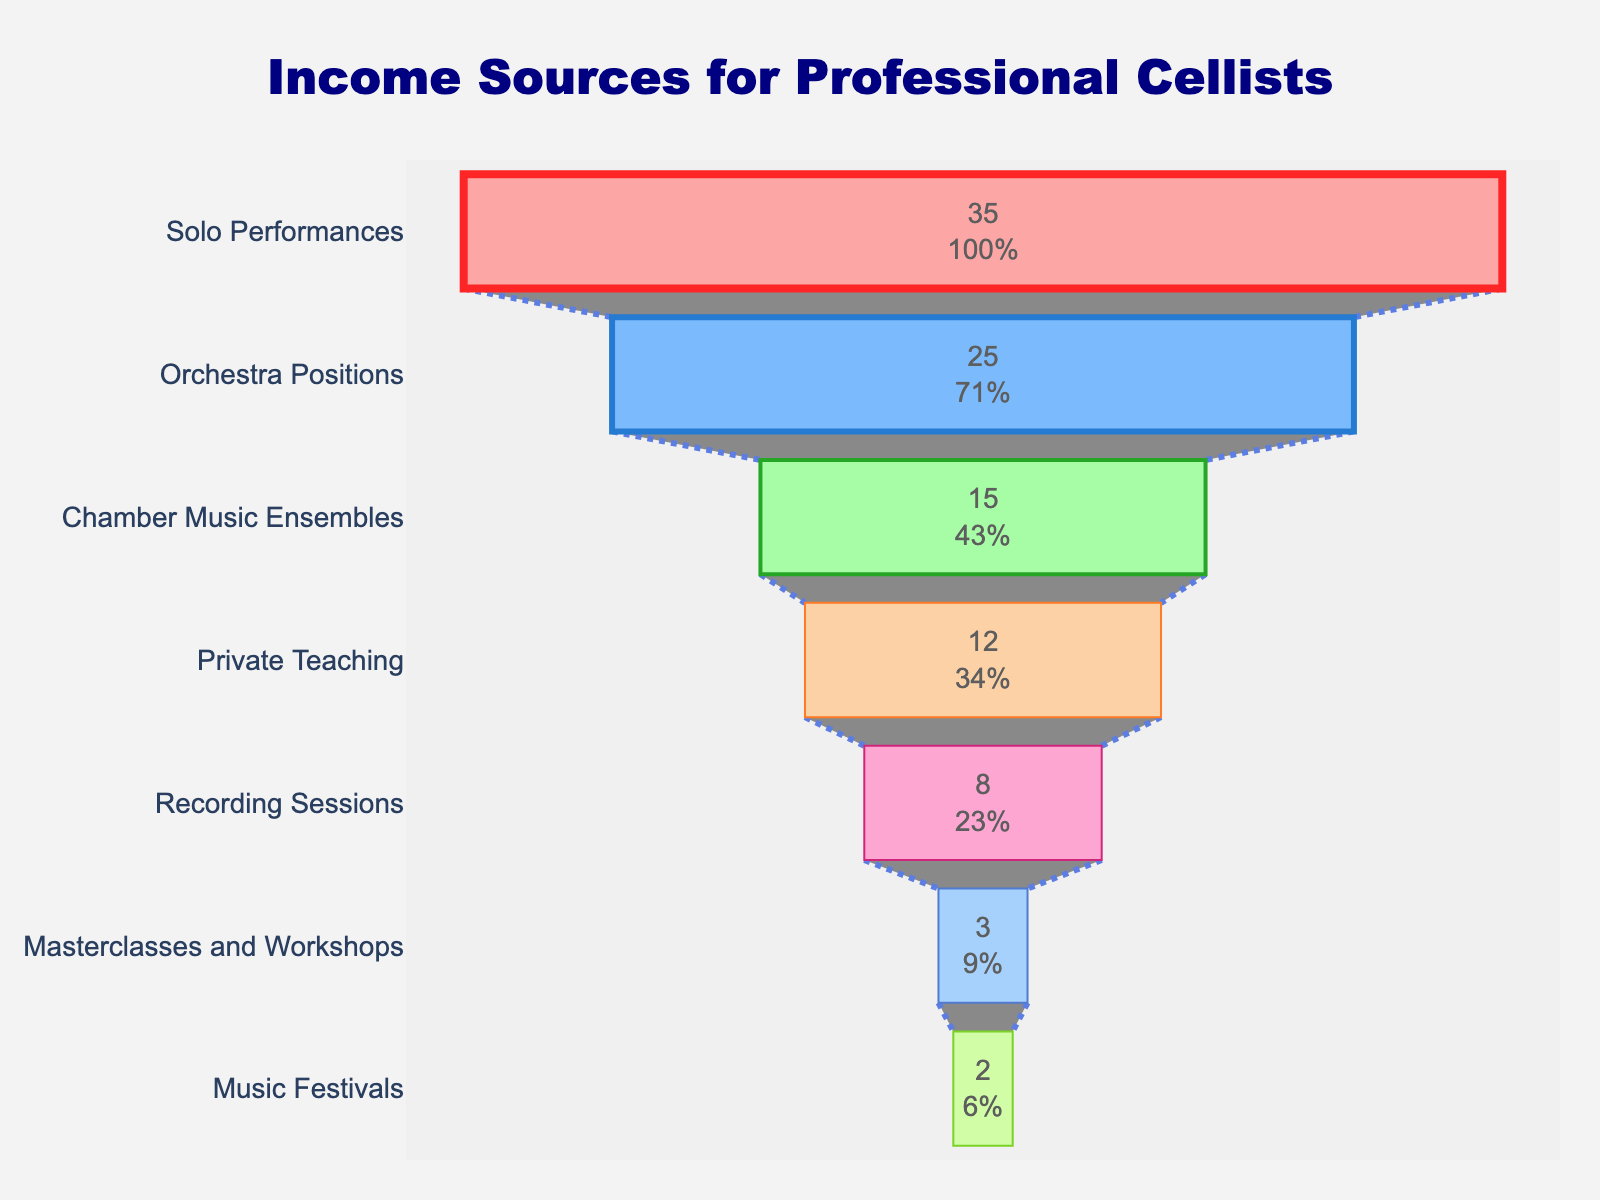What's the highest income source according to the figure? The figure shows different income sources with corresponding percentages. The category with the highest percentage is the primary source.
Answer: Solo Performances Which category contributes the least to income? The figure's lowest segment represents the category with the smallest percentage.
Answer: Music Festivals How do the contributions from Private Teaching and Orchestra Positions compare? Private Teaching has a 12% contribution, while Orchestra Positions have a 25% contribution. Orchestra Positions contribute more.
Answer: Orchestra Positions contribute more What's the combined percentage of Solo Performances and Chamber Music Ensembles? Add the two percentages: Solo Performances (35%) and Chamber Music Ensembles (15%). The combined percentage is 35% + 15% = 50%.
Answer: 50% Which income source has a percentage exactly half of Solo Performances? Solo Performances constitute 35%. Half of 35% is 17.5%. The figure shows no category with a 17.5% share.
Answer: None What is the total percentage of income from performances (Solo Performances, Orchestra Positions, Chamber Music Ensembles)? Summing up Solo Performances (35%), Orchestra Positions (25%), and Chamber Music Ensembles (15%) gives 35% + 25% + 15% = 75%.
Answer: 75% Are there more income sources below or above 10%? By looking at the figure, the categories above 10% are: Solo Performances, Orchestra Positions, Chamber Music Ensembles, and Private Teaching. Below 10%: Recording Sessions, Masterclasses and Workshops, and Music Festivals. There are more categories above 10%.
Answer: More sources above 10% How does the visual thickness relate to each income source? The figure's funnel chart shows thicker segments for higher percentages and thinner ones for smaller percentages.
Answer: Thicker segments mean higher percentages By how much does the Recording Sessions percentage surpass Music Festivals? Recording Sessions have 8% and Music Festivals have 2%. The difference is 8% - 2% = 6%.
Answer: 6% What percentage of income comes from teaching-related activities (Private Teaching and Masterclasses and Workshops)? Add percentages from Private Teaching (12%) and Masterclasses and Workshops (3%). The total is 12% + 3% = 15%.
Answer: 15% 